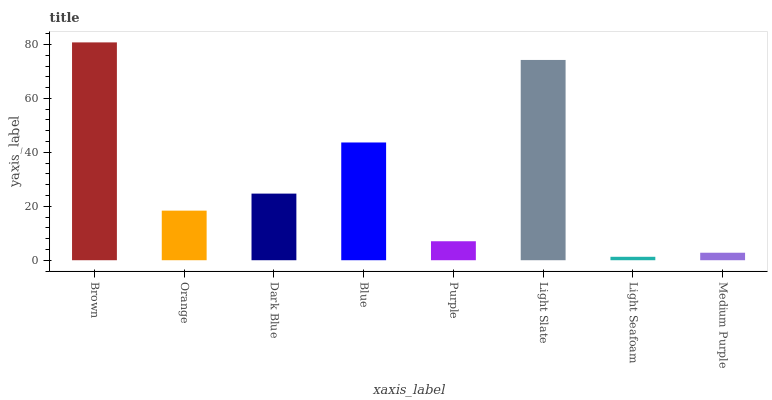Is Light Seafoam the minimum?
Answer yes or no. Yes. Is Brown the maximum?
Answer yes or no. Yes. Is Orange the minimum?
Answer yes or no. No. Is Orange the maximum?
Answer yes or no. No. Is Brown greater than Orange?
Answer yes or no. Yes. Is Orange less than Brown?
Answer yes or no. Yes. Is Orange greater than Brown?
Answer yes or no. No. Is Brown less than Orange?
Answer yes or no. No. Is Dark Blue the high median?
Answer yes or no. Yes. Is Orange the low median?
Answer yes or no. Yes. Is Blue the high median?
Answer yes or no. No. Is Brown the low median?
Answer yes or no. No. 